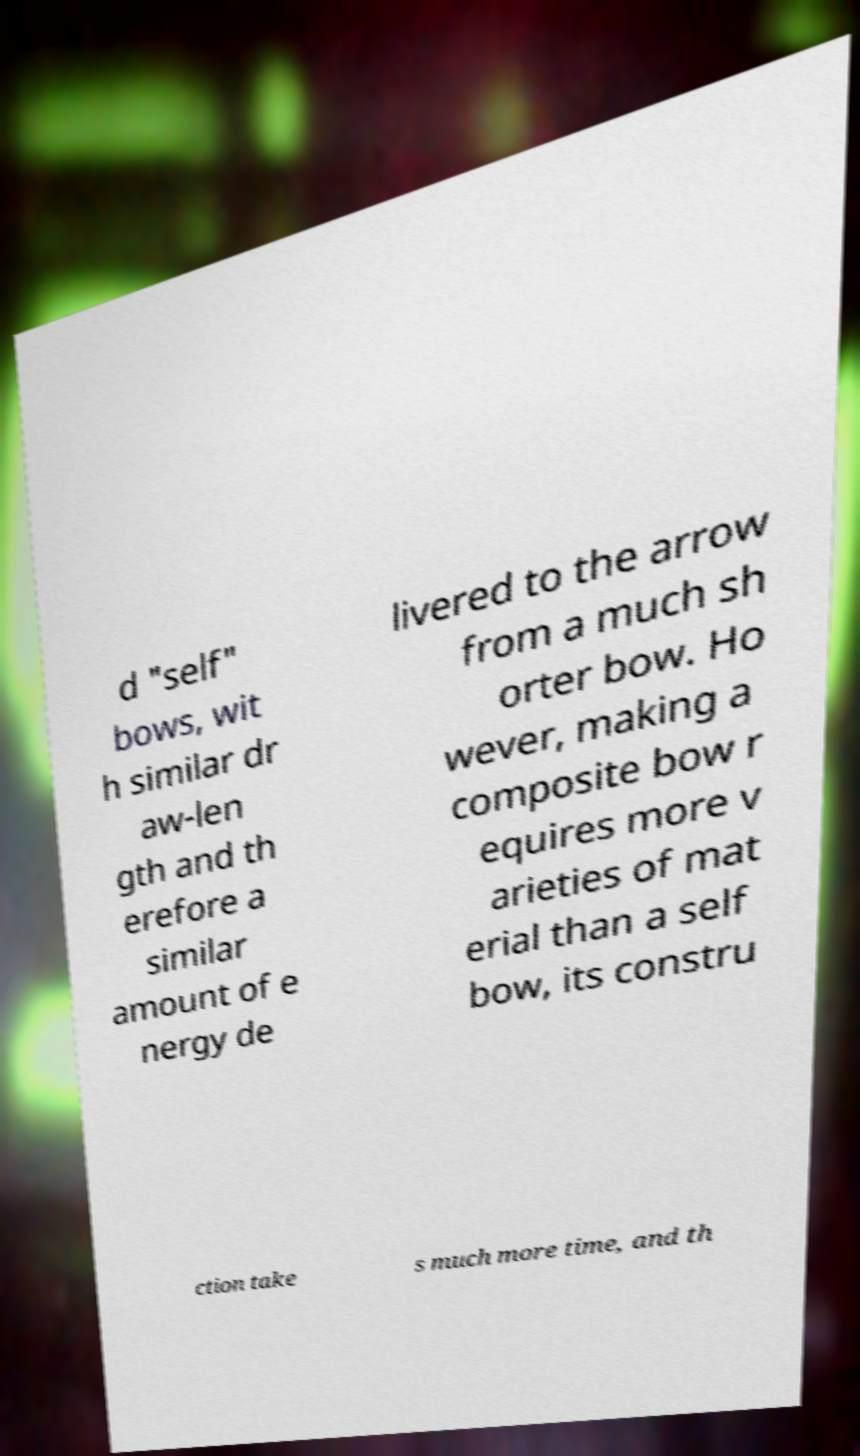Could you assist in decoding the text presented in this image and type it out clearly? d "self" bows, wit h similar dr aw-len gth and th erefore a similar amount of e nergy de livered to the arrow from a much sh orter bow. Ho wever, making a composite bow r equires more v arieties of mat erial than a self bow, its constru ction take s much more time, and th 